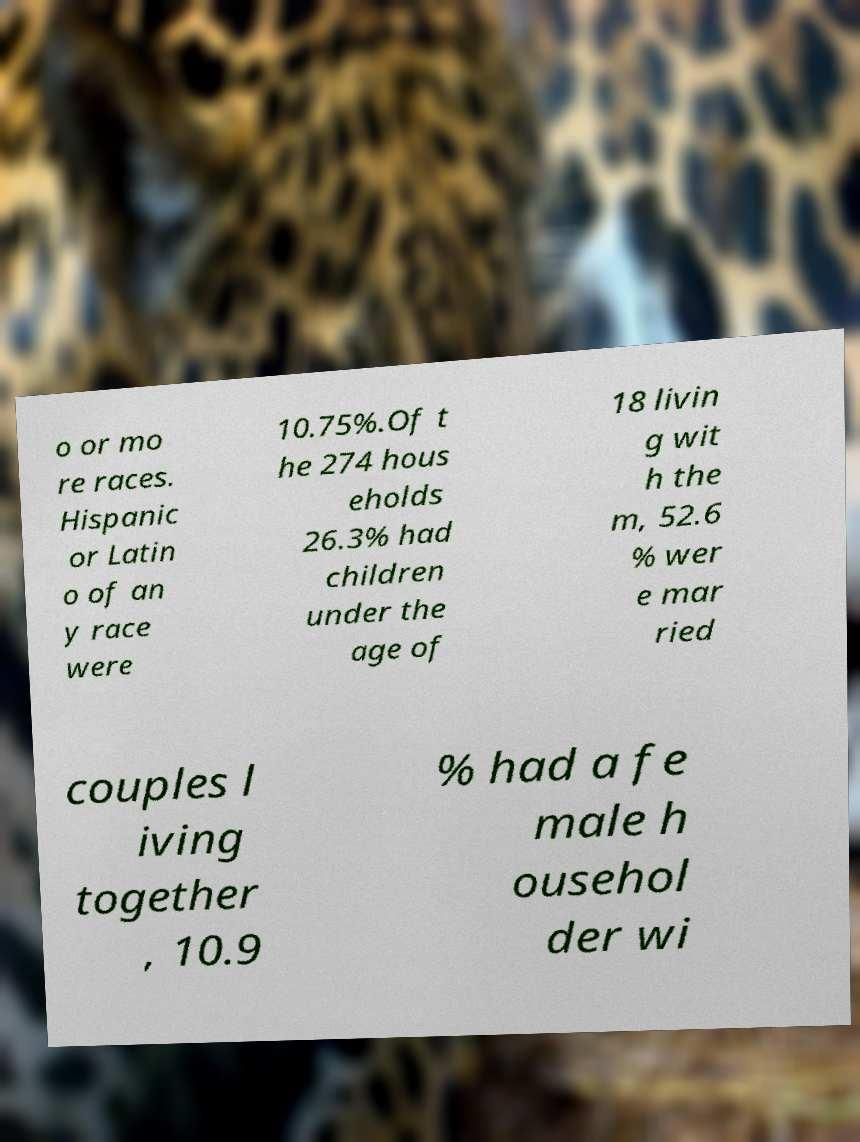I need the written content from this picture converted into text. Can you do that? o or mo re races. Hispanic or Latin o of an y race were 10.75%.Of t he 274 hous eholds 26.3% had children under the age of 18 livin g wit h the m, 52.6 % wer e mar ried couples l iving together , 10.9 % had a fe male h ousehol der wi 